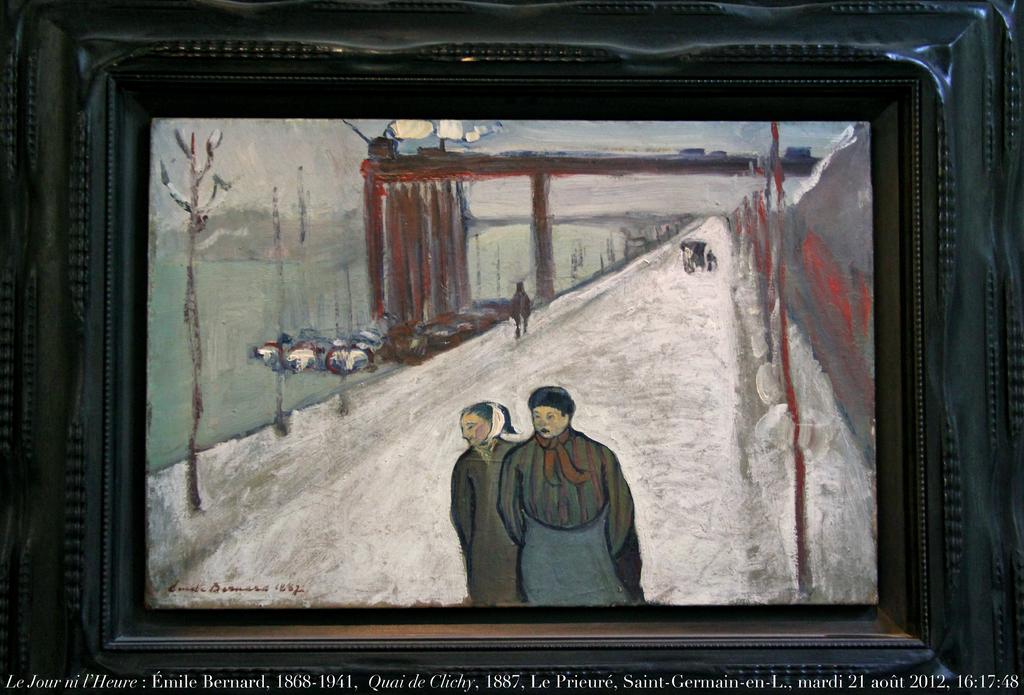Who painted this picture?
Provide a short and direct response. Emile bernard. What year did emile bernard pass away?
Give a very brief answer. 1941. 